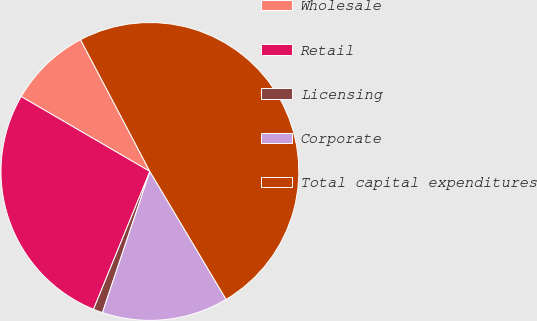Convert chart. <chart><loc_0><loc_0><loc_500><loc_500><pie_chart><fcel>Wholesale<fcel>Retail<fcel>Licensing<fcel>Corporate<fcel>Total capital expenditures<nl><fcel>8.9%<fcel>27.21%<fcel>1.02%<fcel>13.71%<fcel>49.16%<nl></chart> 